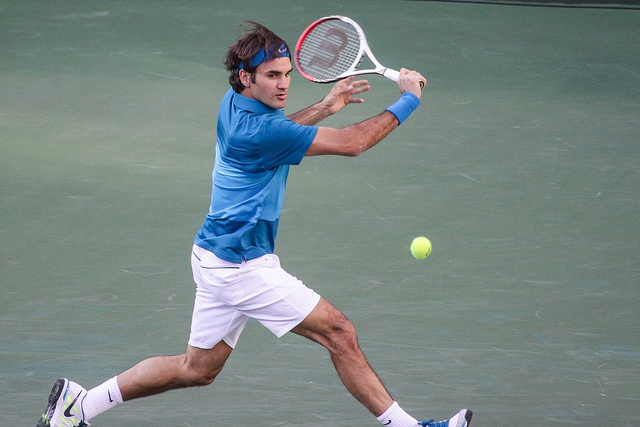Describe the objects in this image and their specific colors. I can see people in gray, lavender, brown, blue, and lightblue tones, tennis racket in gray, darkgray, and lavender tones, and sports ball in gray, khaki, lightgreen, and darkgray tones in this image. 